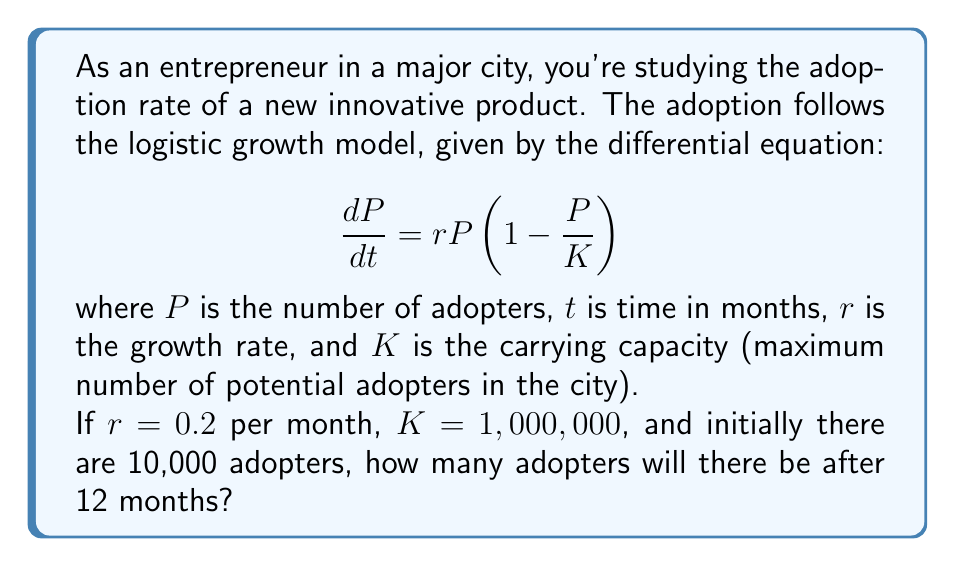Help me with this question. To solve this problem, we need to use the solution to the logistic differential equation:

$$P(t) = \frac{K}{1 + (\frac{K}{P_0} - 1)e^{-rt}}$$

Where $P_0$ is the initial number of adopters.

Step 1: Identify the given values
$r = 0.2$ per month
$K = 1,000,000$
$P_0 = 10,000$
$t = 12$ months

Step 2: Substitute these values into the equation
$$P(12) = \frac{1,000,000}{1 + (\frac{1,000,000}{10,000} - 1)e^{-0.2(12)}}$$

Step 3: Simplify the expression inside the parentheses
$$P(12) = \frac{1,000,000}{1 + (99)e^{-2.4}}$$

Step 4: Calculate $e^{-2.4}$
$e^{-2.4} \approx 0.0907$

Step 5: Multiply inside the parentheses
$$P(12) = \frac{1,000,000}{1 + 99(0.0907)} = \frac{1,000,000}{1 + 8.9793}$$

Step 6: Add 1 to 8.9793
$$P(12) = \frac{1,000,000}{9.9793}$$

Step 7: Divide
$$P(12) \approx 100,207$$

Therefore, after 12 months, there will be approximately 100,207 adopters.
Answer: 100,207 adopters 